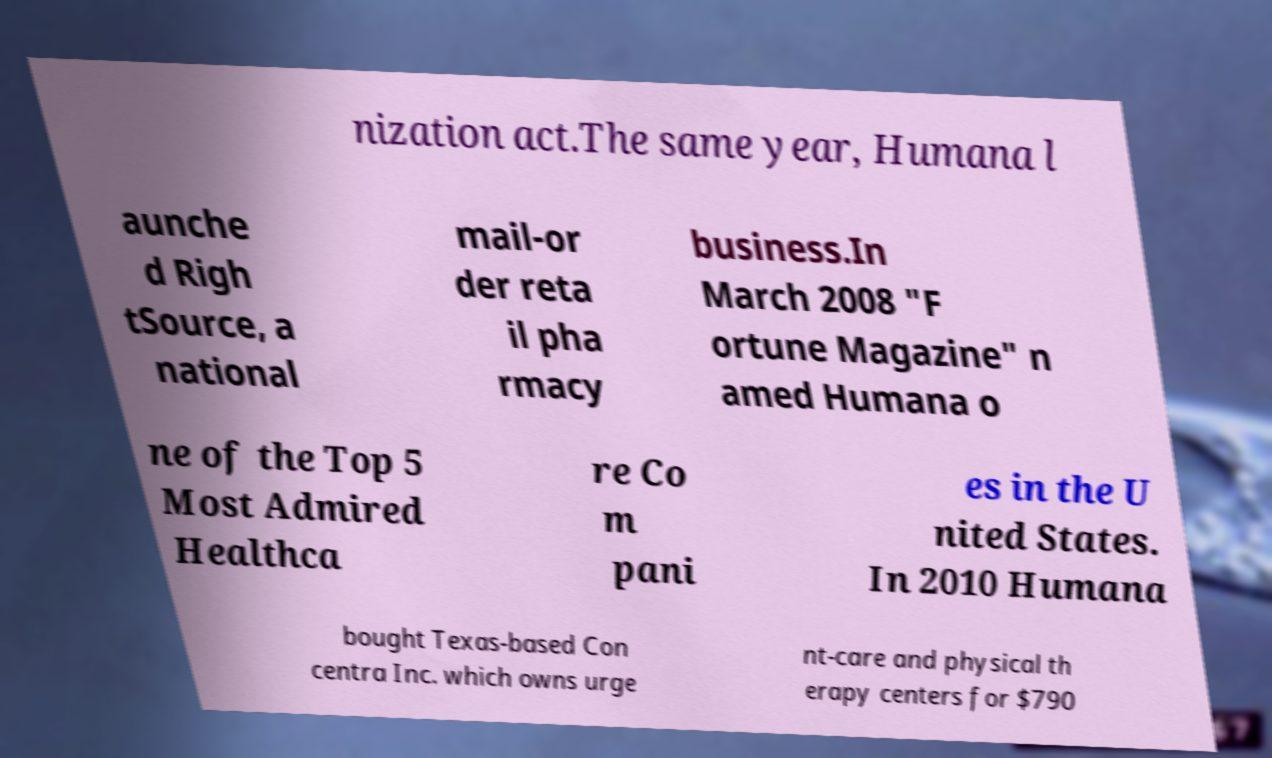Can you accurately transcribe the text from the provided image for me? nization act.The same year, Humana l aunche d Righ tSource, a national mail-or der reta il pha rmacy business.In March 2008 "F ortune Magazine" n amed Humana o ne of the Top 5 Most Admired Healthca re Co m pani es in the U nited States. In 2010 Humana bought Texas-based Con centra Inc. which owns urge nt-care and physical th erapy centers for $790 